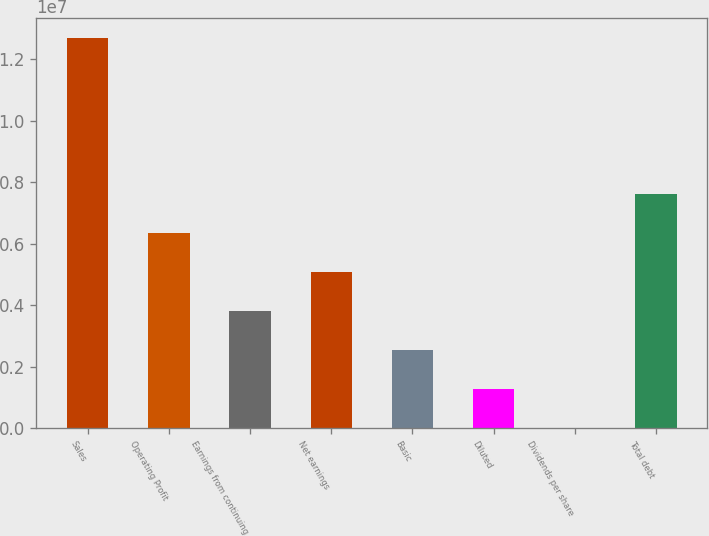Convert chart. <chart><loc_0><loc_0><loc_500><loc_500><bar_chart><fcel>Sales<fcel>Operating Profit<fcel>Earnings from continuing<fcel>Net earnings<fcel>Basic<fcel>Diluted<fcel>Dividends per share<fcel>Total debt<nl><fcel>1.26975e+07<fcel>6.34873e+06<fcel>3.80924e+06<fcel>5.07898e+06<fcel>2.53949e+06<fcel>1.26975e+06<fcel>0.12<fcel>7.61847e+06<nl></chart> 